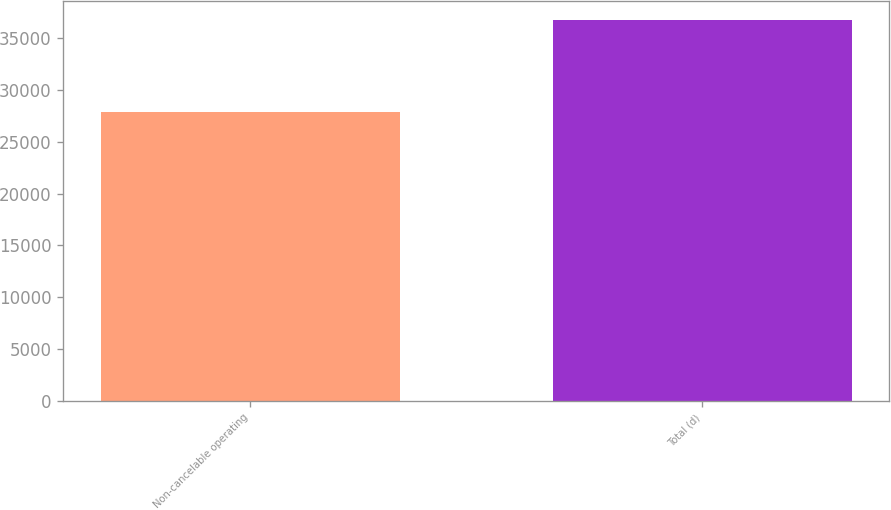<chart> <loc_0><loc_0><loc_500><loc_500><bar_chart><fcel>Non-cancelable operating<fcel>Total (d)<nl><fcel>27903<fcel>36757<nl></chart> 